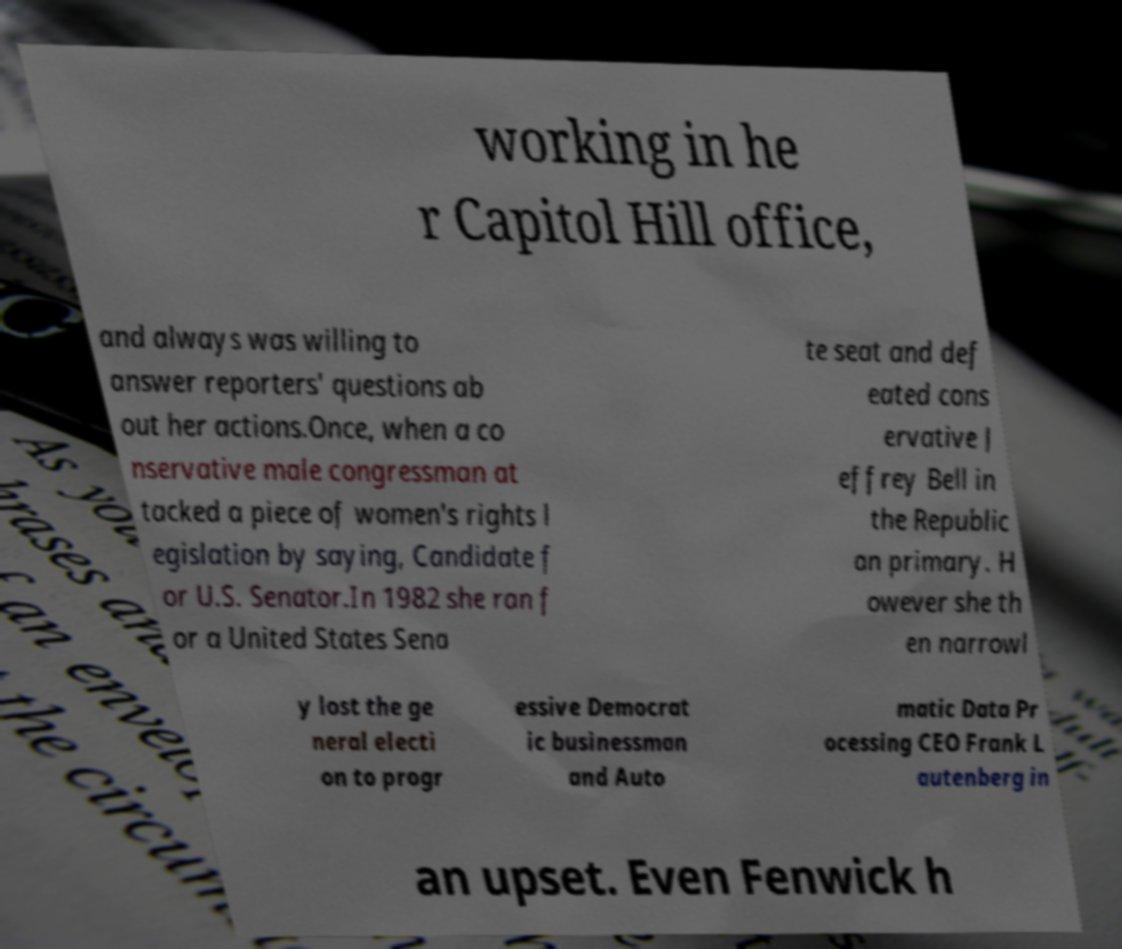Can you accurately transcribe the text from the provided image for me? working in he r Capitol Hill office, and always was willing to answer reporters' questions ab out her actions.Once, when a co nservative male congressman at tacked a piece of women's rights l egislation by saying, Candidate f or U.S. Senator.In 1982 she ran f or a United States Sena te seat and def eated cons ervative J effrey Bell in the Republic an primary. H owever she th en narrowl y lost the ge neral electi on to progr essive Democrat ic businessman and Auto matic Data Pr ocessing CEO Frank L autenberg in an upset. Even Fenwick h 